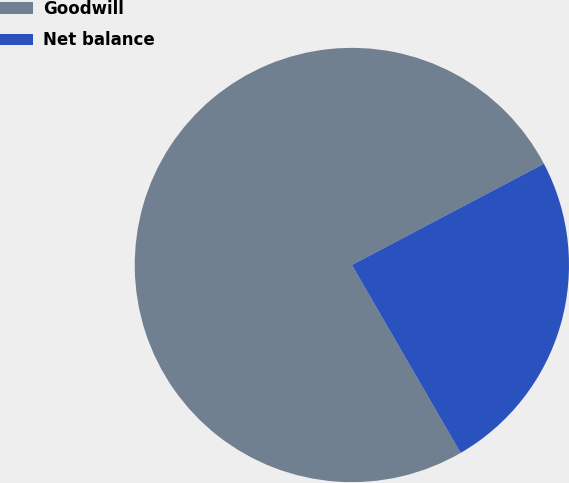<chart> <loc_0><loc_0><loc_500><loc_500><pie_chart><fcel>Goodwill<fcel>Net balance<nl><fcel>75.63%<fcel>24.37%<nl></chart> 